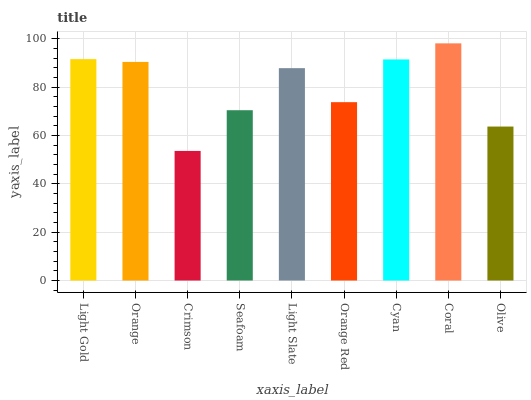Is Orange the minimum?
Answer yes or no. No. Is Orange the maximum?
Answer yes or no. No. Is Light Gold greater than Orange?
Answer yes or no. Yes. Is Orange less than Light Gold?
Answer yes or no. Yes. Is Orange greater than Light Gold?
Answer yes or no. No. Is Light Gold less than Orange?
Answer yes or no. No. Is Light Slate the high median?
Answer yes or no. Yes. Is Light Slate the low median?
Answer yes or no. Yes. Is Coral the high median?
Answer yes or no. No. Is Orange Red the low median?
Answer yes or no. No. 